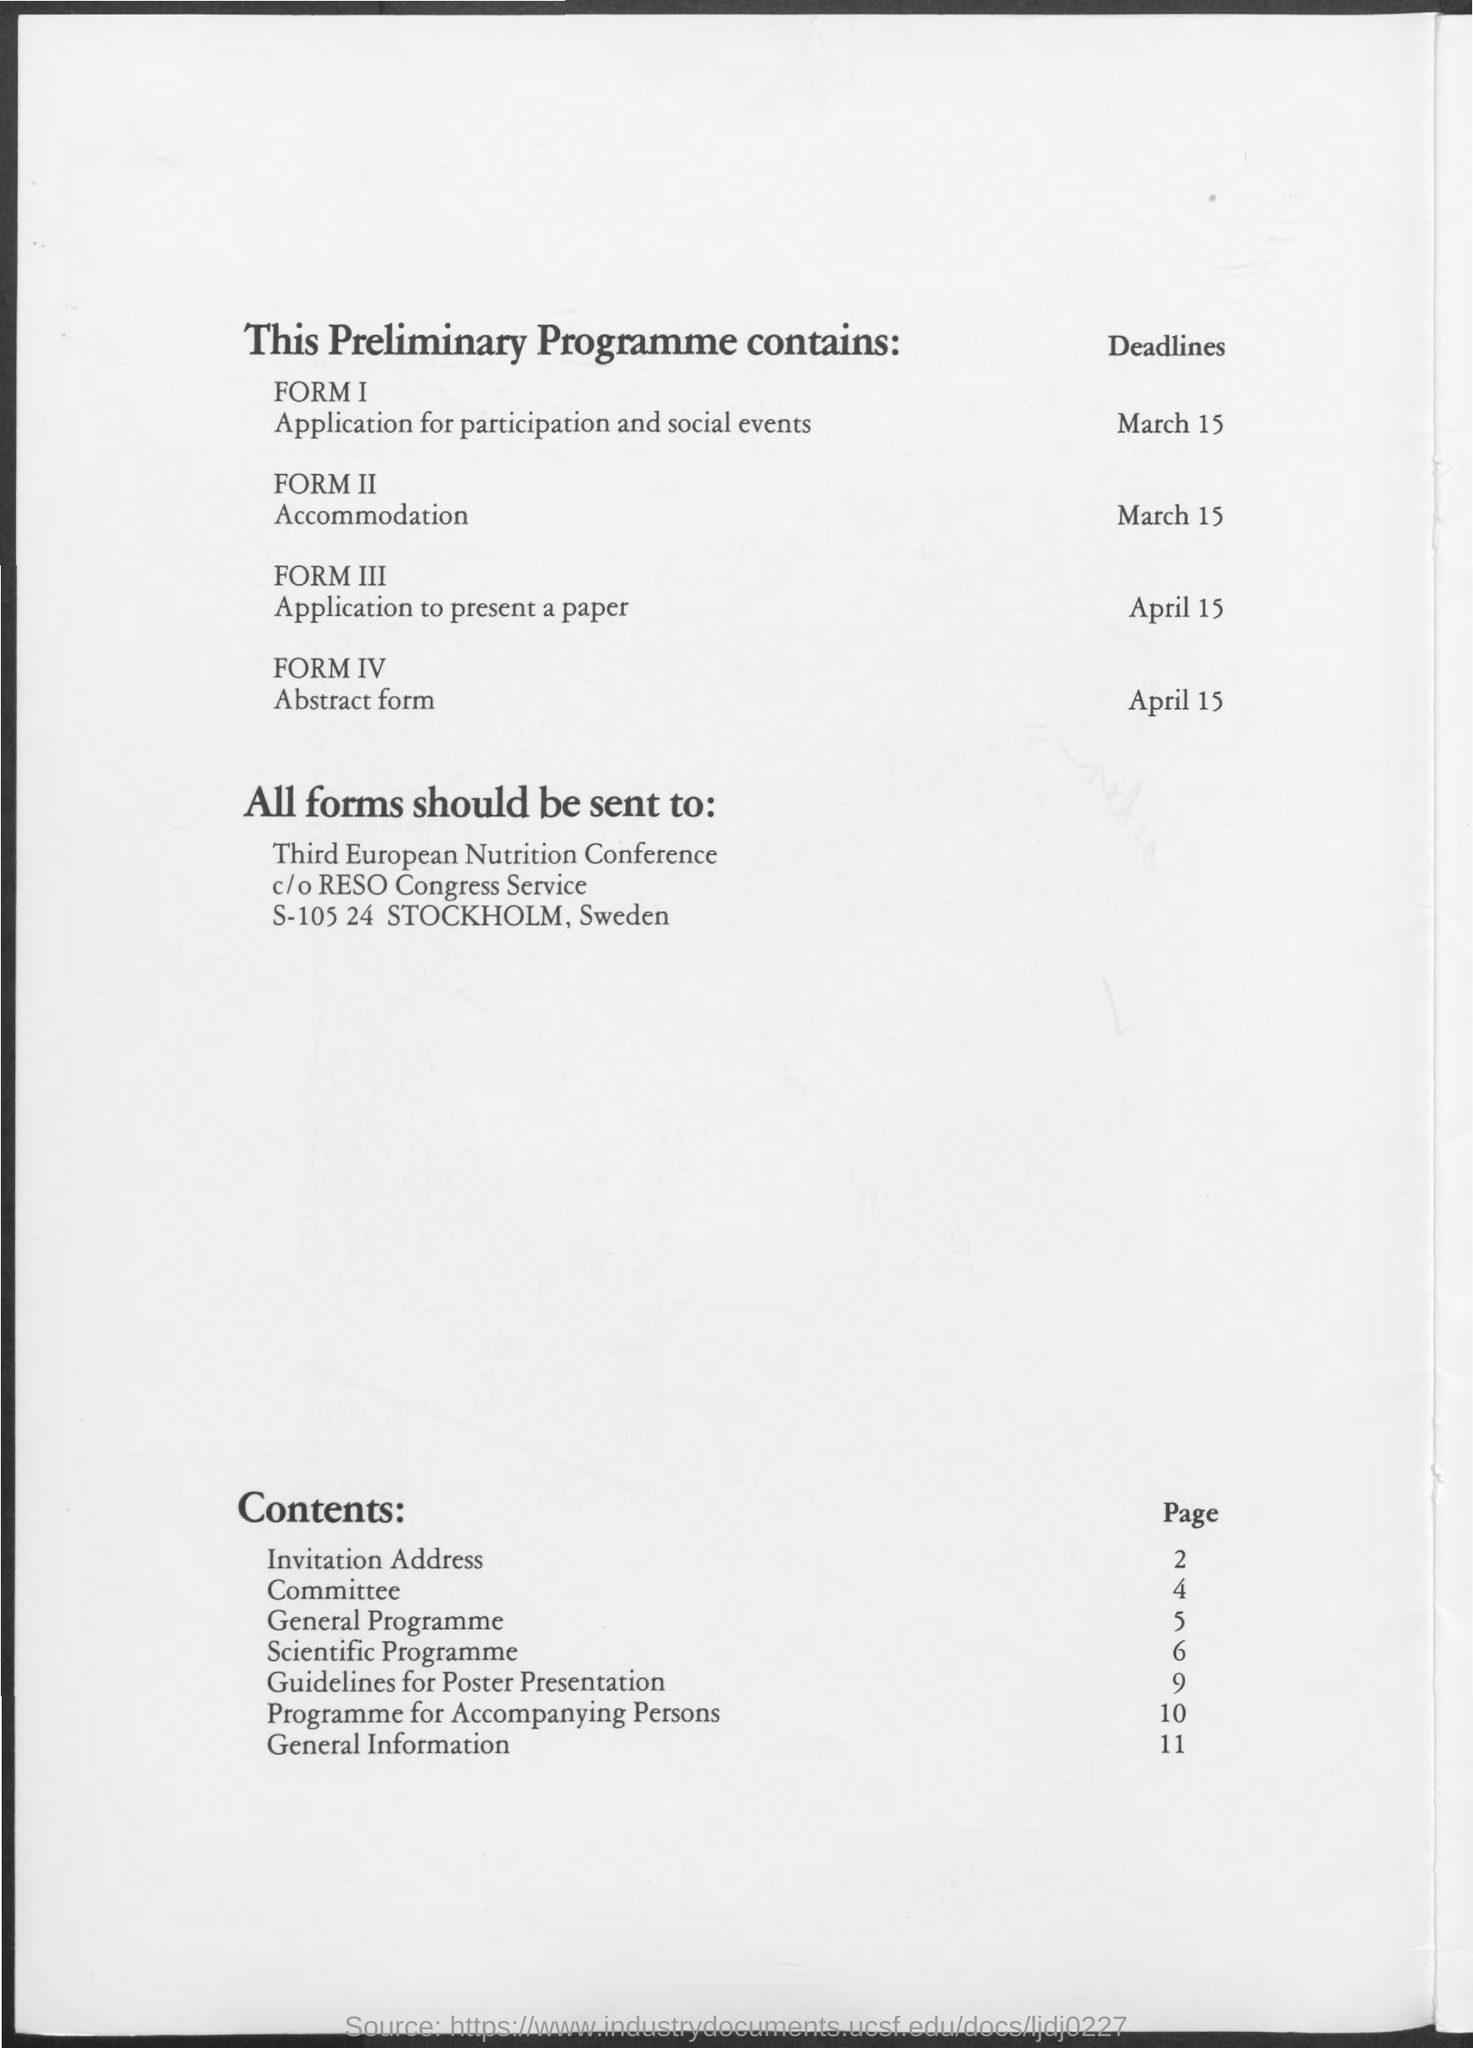Draw attention to some important aspects in this diagram. The page number for General Information is 11. The deadline for Application for Participation and social events is March 15. The deadline for accommodation is March 15. The deadline for submitting the Abstract form is April 15. The page number for the General Programme is 5. 